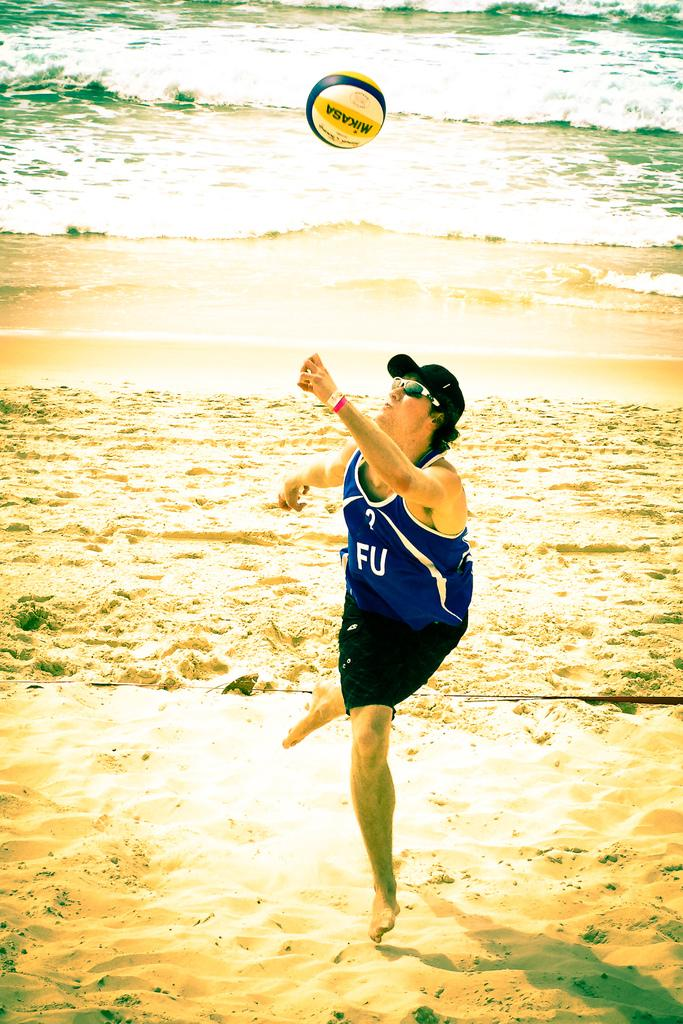Who is present in the image? There is a man in the image. What is the man doing in the image? The man is playing with a ball. Where is the location of the image? The location is at a seaside. What can be seen behind the man in the image? There is a beach behind the man. What type of air is present in the image? There is no specific mention of air in the image, but it can be assumed that the air is normal, as there are no indications of unusual conditions. 